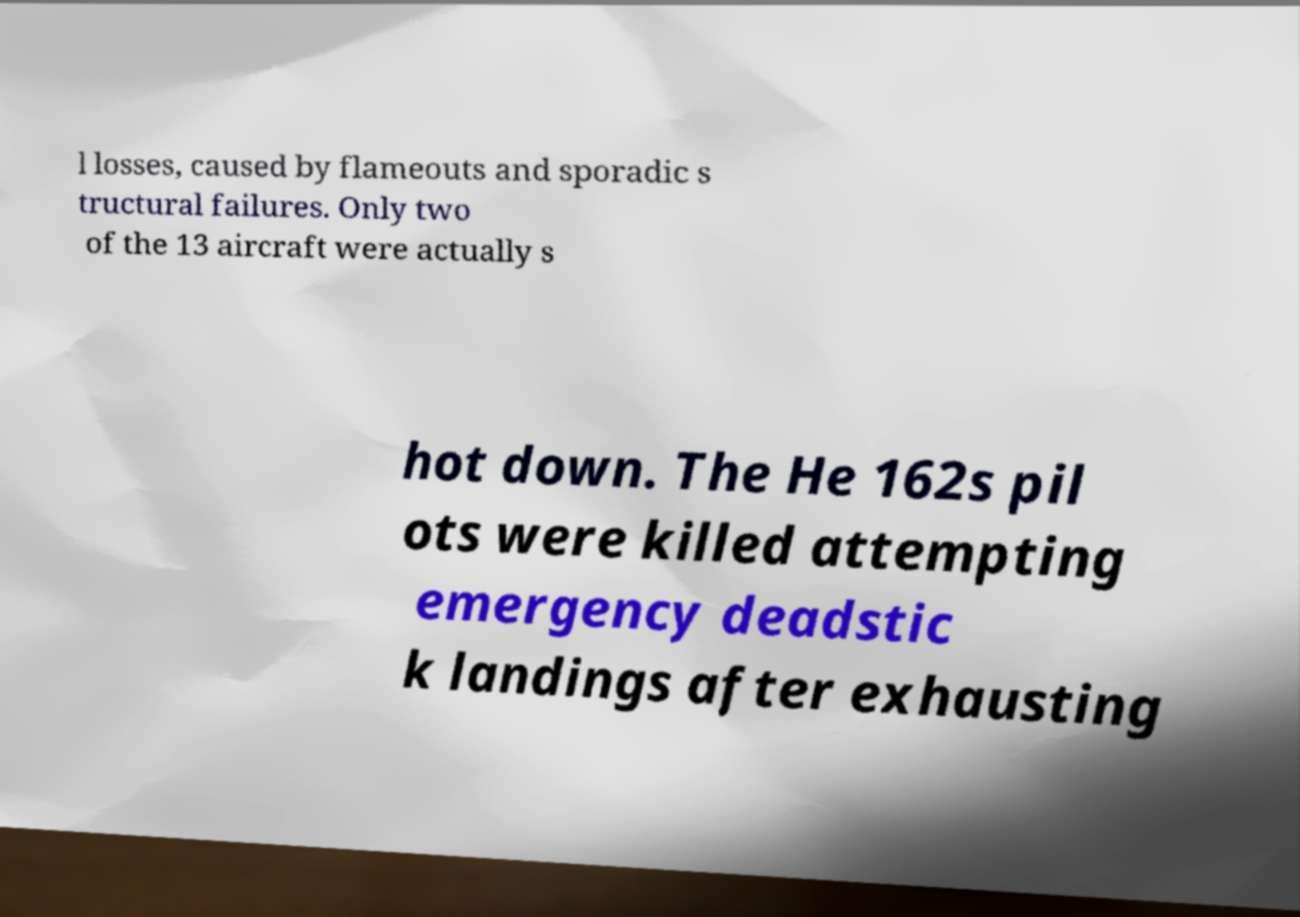What messages or text are displayed in this image? I need them in a readable, typed format. l losses, caused by flameouts and sporadic s tructural failures. Only two of the 13 aircraft were actually s hot down. The He 162s pil ots were killed attempting emergency deadstic k landings after exhausting 